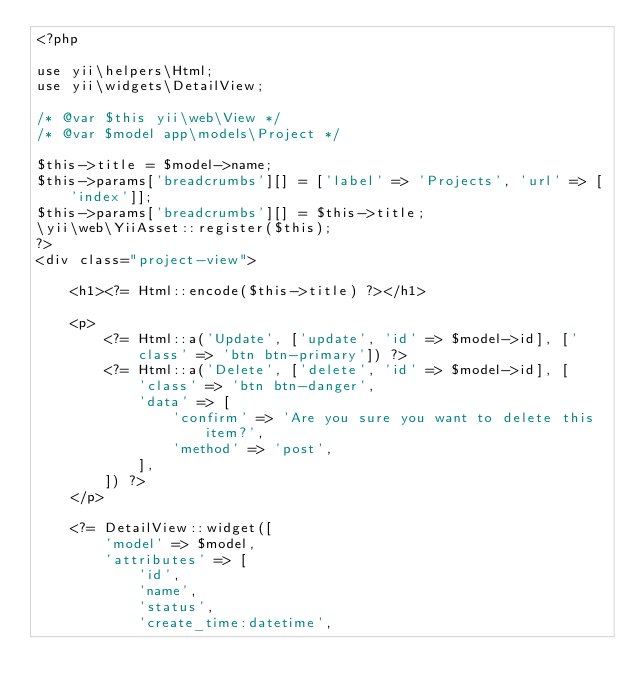<code> <loc_0><loc_0><loc_500><loc_500><_PHP_><?php

use yii\helpers\Html;
use yii\widgets\DetailView;

/* @var $this yii\web\View */
/* @var $model app\models\Project */

$this->title = $model->name;
$this->params['breadcrumbs'][] = ['label' => 'Projects', 'url' => ['index']];
$this->params['breadcrumbs'][] = $this->title;
\yii\web\YiiAsset::register($this);
?>
<div class="project-view">

    <h1><?= Html::encode($this->title) ?></h1>

    <p>
        <?= Html::a('Update', ['update', 'id' => $model->id], ['class' => 'btn btn-primary']) ?>
        <?= Html::a('Delete', ['delete', 'id' => $model->id], [
            'class' => 'btn btn-danger',
            'data' => [
                'confirm' => 'Are you sure you want to delete this item?',
                'method' => 'post',
            ],
        ]) ?>
    </p>

    <?= DetailView::widget([
        'model' => $model,
        'attributes' => [
            'id',
            'name',
            'status',
            'create_time:datetime',</code> 